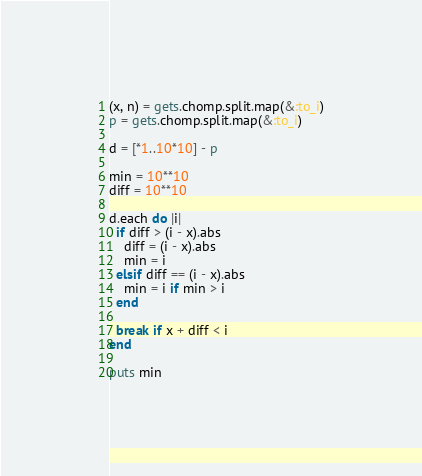<code> <loc_0><loc_0><loc_500><loc_500><_Ruby_>(x, n) = gets.chomp.split.map(&:to_i)
p = gets.chomp.split.map(&:to_i)

d = [*1..10*10] - p

min = 10**10
diff = 10**10

d.each do |i|
  if diff > (i - x).abs
    diff = (i - x).abs
    min = i
  elsif diff == (i - x).abs
    min = i if min > i
  end

  break if x + diff < i
end

puts min
</code> 